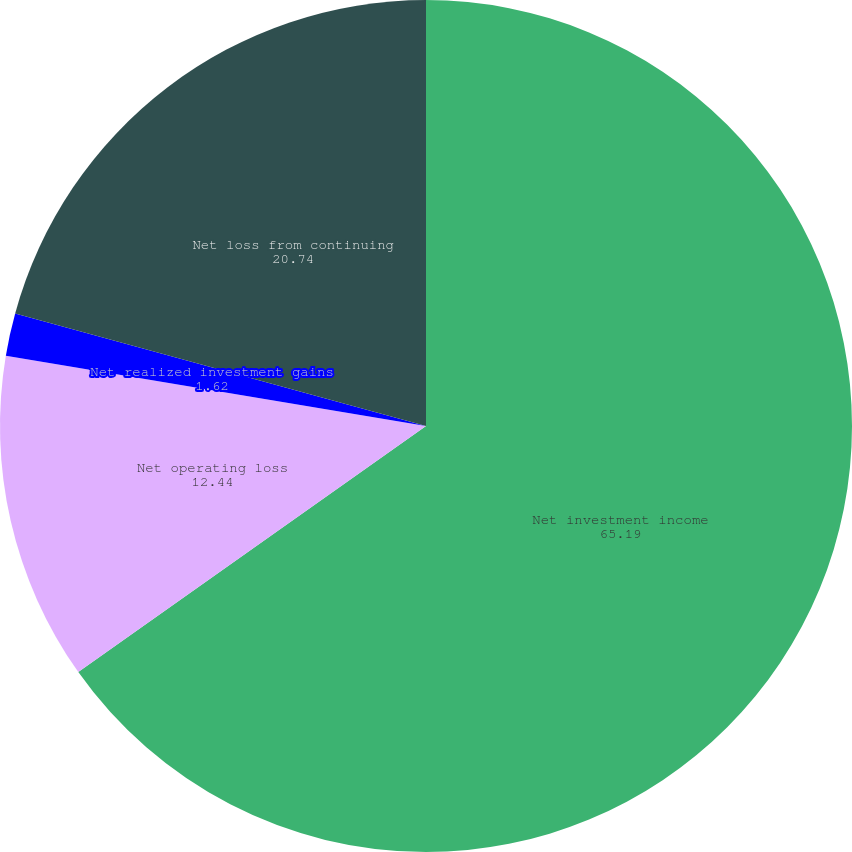Convert chart. <chart><loc_0><loc_0><loc_500><loc_500><pie_chart><fcel>Net investment income<fcel>Net operating loss<fcel>Net realized investment gains<fcel>Net loss from continuing<nl><fcel>65.19%<fcel>12.44%<fcel>1.62%<fcel>20.74%<nl></chart> 